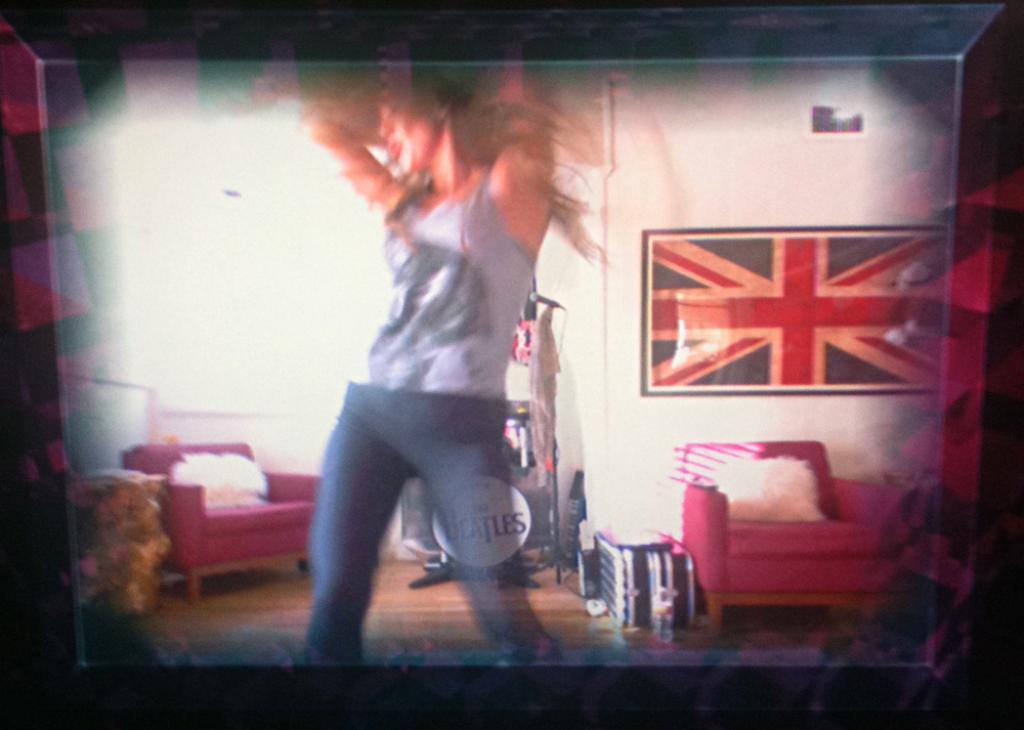Can you describe this image briefly? In this picture there is a photo frame of a photo. In the photo there is a woman wearing a grey t shirt, grey trousers and she is dancing. Towards the left and right, there are sofas which are in red in color. Towards the right, there is a wall with a chart. 